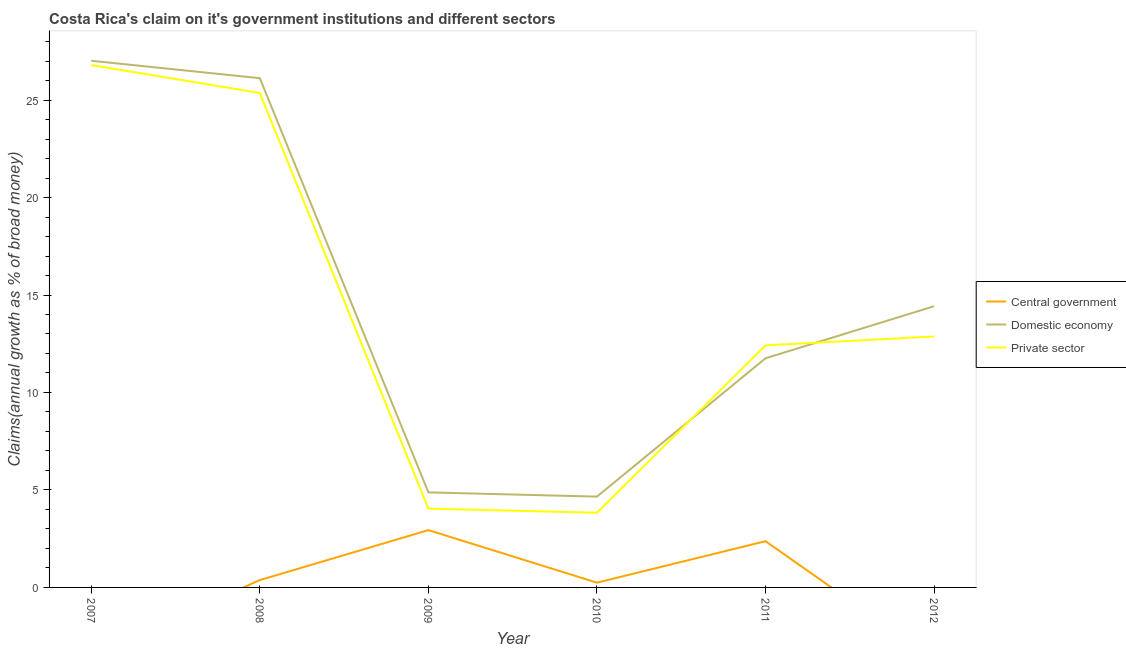Does the line corresponding to percentage of claim on the private sector intersect with the line corresponding to percentage of claim on the domestic economy?
Make the answer very short. Yes. What is the percentage of claim on the domestic economy in 2011?
Your response must be concise. 11.75. Across all years, what is the maximum percentage of claim on the domestic economy?
Provide a succinct answer. 27.02. In which year was the percentage of claim on the private sector maximum?
Ensure brevity in your answer.  2007. What is the total percentage of claim on the central government in the graph?
Keep it short and to the point. 5.93. What is the difference between the percentage of claim on the private sector in 2007 and that in 2010?
Your response must be concise. 22.96. What is the difference between the percentage of claim on the domestic economy in 2012 and the percentage of claim on the private sector in 2009?
Offer a terse response. 10.38. What is the average percentage of claim on the domestic economy per year?
Give a very brief answer. 14.81. In the year 2008, what is the difference between the percentage of claim on the domestic economy and percentage of claim on the central government?
Your response must be concise. 25.75. In how many years, is the percentage of claim on the central government greater than 16 %?
Offer a very short reply. 0. What is the ratio of the percentage of claim on the private sector in 2007 to that in 2009?
Your response must be concise. 6.63. Is the percentage of claim on the private sector in 2009 less than that in 2011?
Your response must be concise. Yes. Is the difference between the percentage of claim on the central government in 2008 and 2010 greater than the difference between the percentage of claim on the private sector in 2008 and 2010?
Your answer should be compact. No. What is the difference between the highest and the second highest percentage of claim on the domestic economy?
Give a very brief answer. 0.89. What is the difference between the highest and the lowest percentage of claim on the domestic economy?
Give a very brief answer. 22.36. Is it the case that in every year, the sum of the percentage of claim on the central government and percentage of claim on the domestic economy is greater than the percentage of claim on the private sector?
Offer a very short reply. Yes. Does the percentage of claim on the central government monotonically increase over the years?
Provide a succinct answer. No. Is the percentage of claim on the domestic economy strictly greater than the percentage of claim on the central government over the years?
Offer a terse response. Yes. Is the percentage of claim on the domestic economy strictly less than the percentage of claim on the private sector over the years?
Your answer should be very brief. No. How many lines are there?
Offer a terse response. 3. How many years are there in the graph?
Offer a terse response. 6. What is the difference between two consecutive major ticks on the Y-axis?
Provide a succinct answer. 5. Are the values on the major ticks of Y-axis written in scientific E-notation?
Keep it short and to the point. No. Does the graph contain any zero values?
Offer a very short reply. Yes. Does the graph contain grids?
Keep it short and to the point. No. How many legend labels are there?
Keep it short and to the point. 3. How are the legend labels stacked?
Your answer should be compact. Vertical. What is the title of the graph?
Your answer should be compact. Costa Rica's claim on it's government institutions and different sectors. Does "Solid fuel" appear as one of the legend labels in the graph?
Provide a succinct answer. No. What is the label or title of the X-axis?
Provide a short and direct response. Year. What is the label or title of the Y-axis?
Ensure brevity in your answer.  Claims(annual growth as % of broad money). What is the Claims(annual growth as % of broad money) of Central government in 2007?
Ensure brevity in your answer.  0. What is the Claims(annual growth as % of broad money) in Domestic economy in 2007?
Give a very brief answer. 27.02. What is the Claims(annual growth as % of broad money) in Private sector in 2007?
Your answer should be very brief. 26.8. What is the Claims(annual growth as % of broad money) of Central government in 2008?
Your response must be concise. 0.38. What is the Claims(annual growth as % of broad money) in Domestic economy in 2008?
Offer a terse response. 26.12. What is the Claims(annual growth as % of broad money) in Private sector in 2008?
Offer a terse response. 25.36. What is the Claims(annual growth as % of broad money) of Central government in 2009?
Provide a succinct answer. 2.94. What is the Claims(annual growth as % of broad money) of Domestic economy in 2009?
Offer a terse response. 4.88. What is the Claims(annual growth as % of broad money) in Private sector in 2009?
Your answer should be very brief. 4.04. What is the Claims(annual growth as % of broad money) in Central government in 2010?
Offer a very short reply. 0.24. What is the Claims(annual growth as % of broad money) in Domestic economy in 2010?
Provide a short and direct response. 4.66. What is the Claims(annual growth as % of broad money) of Private sector in 2010?
Offer a terse response. 3.83. What is the Claims(annual growth as % of broad money) in Central government in 2011?
Your answer should be very brief. 2.37. What is the Claims(annual growth as % of broad money) in Domestic economy in 2011?
Give a very brief answer. 11.75. What is the Claims(annual growth as % of broad money) of Private sector in 2011?
Provide a succinct answer. 12.42. What is the Claims(annual growth as % of broad money) of Domestic economy in 2012?
Your answer should be very brief. 14.42. What is the Claims(annual growth as % of broad money) in Private sector in 2012?
Your response must be concise. 12.87. Across all years, what is the maximum Claims(annual growth as % of broad money) in Central government?
Your answer should be very brief. 2.94. Across all years, what is the maximum Claims(annual growth as % of broad money) of Domestic economy?
Give a very brief answer. 27.02. Across all years, what is the maximum Claims(annual growth as % of broad money) in Private sector?
Keep it short and to the point. 26.8. Across all years, what is the minimum Claims(annual growth as % of broad money) in Central government?
Keep it short and to the point. 0. Across all years, what is the minimum Claims(annual growth as % of broad money) in Domestic economy?
Offer a very short reply. 4.66. Across all years, what is the minimum Claims(annual growth as % of broad money) in Private sector?
Provide a succinct answer. 3.83. What is the total Claims(annual growth as % of broad money) in Central government in the graph?
Ensure brevity in your answer.  5.93. What is the total Claims(annual growth as % of broad money) of Domestic economy in the graph?
Offer a very short reply. 88.85. What is the total Claims(annual growth as % of broad money) of Private sector in the graph?
Your response must be concise. 85.32. What is the difference between the Claims(annual growth as % of broad money) of Domestic economy in 2007 and that in 2008?
Provide a short and direct response. 0.89. What is the difference between the Claims(annual growth as % of broad money) of Private sector in 2007 and that in 2008?
Your answer should be compact. 1.43. What is the difference between the Claims(annual growth as % of broad money) of Domestic economy in 2007 and that in 2009?
Provide a succinct answer. 22.14. What is the difference between the Claims(annual growth as % of broad money) of Private sector in 2007 and that in 2009?
Provide a short and direct response. 22.75. What is the difference between the Claims(annual growth as % of broad money) of Domestic economy in 2007 and that in 2010?
Make the answer very short. 22.36. What is the difference between the Claims(annual growth as % of broad money) in Private sector in 2007 and that in 2010?
Provide a succinct answer. 22.96. What is the difference between the Claims(annual growth as % of broad money) in Domestic economy in 2007 and that in 2011?
Offer a terse response. 15.26. What is the difference between the Claims(annual growth as % of broad money) of Private sector in 2007 and that in 2011?
Your answer should be compact. 14.38. What is the difference between the Claims(annual growth as % of broad money) in Domestic economy in 2007 and that in 2012?
Provide a short and direct response. 12.59. What is the difference between the Claims(annual growth as % of broad money) of Private sector in 2007 and that in 2012?
Ensure brevity in your answer.  13.92. What is the difference between the Claims(annual growth as % of broad money) of Central government in 2008 and that in 2009?
Provide a short and direct response. -2.56. What is the difference between the Claims(annual growth as % of broad money) of Domestic economy in 2008 and that in 2009?
Give a very brief answer. 21.25. What is the difference between the Claims(annual growth as % of broad money) of Private sector in 2008 and that in 2009?
Your response must be concise. 21.32. What is the difference between the Claims(annual growth as % of broad money) of Central government in 2008 and that in 2010?
Provide a short and direct response. 0.13. What is the difference between the Claims(annual growth as % of broad money) in Domestic economy in 2008 and that in 2010?
Provide a short and direct response. 21.46. What is the difference between the Claims(annual growth as % of broad money) in Private sector in 2008 and that in 2010?
Give a very brief answer. 21.53. What is the difference between the Claims(annual growth as % of broad money) of Central government in 2008 and that in 2011?
Ensure brevity in your answer.  -2. What is the difference between the Claims(annual growth as % of broad money) of Domestic economy in 2008 and that in 2011?
Ensure brevity in your answer.  14.37. What is the difference between the Claims(annual growth as % of broad money) of Private sector in 2008 and that in 2011?
Offer a very short reply. 12.94. What is the difference between the Claims(annual growth as % of broad money) of Domestic economy in 2008 and that in 2012?
Give a very brief answer. 11.7. What is the difference between the Claims(annual growth as % of broad money) in Private sector in 2008 and that in 2012?
Offer a terse response. 12.49. What is the difference between the Claims(annual growth as % of broad money) of Central government in 2009 and that in 2010?
Offer a very short reply. 2.7. What is the difference between the Claims(annual growth as % of broad money) in Domestic economy in 2009 and that in 2010?
Make the answer very short. 0.22. What is the difference between the Claims(annual growth as % of broad money) in Private sector in 2009 and that in 2010?
Give a very brief answer. 0.21. What is the difference between the Claims(annual growth as % of broad money) of Central government in 2009 and that in 2011?
Keep it short and to the point. 0.57. What is the difference between the Claims(annual growth as % of broad money) of Domestic economy in 2009 and that in 2011?
Your answer should be compact. -6.88. What is the difference between the Claims(annual growth as % of broad money) in Private sector in 2009 and that in 2011?
Ensure brevity in your answer.  -8.38. What is the difference between the Claims(annual growth as % of broad money) of Domestic economy in 2009 and that in 2012?
Your answer should be very brief. -9.55. What is the difference between the Claims(annual growth as % of broad money) in Private sector in 2009 and that in 2012?
Provide a short and direct response. -8.83. What is the difference between the Claims(annual growth as % of broad money) in Central government in 2010 and that in 2011?
Your answer should be compact. -2.13. What is the difference between the Claims(annual growth as % of broad money) in Domestic economy in 2010 and that in 2011?
Your response must be concise. -7.1. What is the difference between the Claims(annual growth as % of broad money) of Private sector in 2010 and that in 2011?
Give a very brief answer. -8.58. What is the difference between the Claims(annual growth as % of broad money) in Domestic economy in 2010 and that in 2012?
Give a very brief answer. -9.77. What is the difference between the Claims(annual growth as % of broad money) in Private sector in 2010 and that in 2012?
Make the answer very short. -9.04. What is the difference between the Claims(annual growth as % of broad money) in Domestic economy in 2011 and that in 2012?
Your answer should be compact. -2.67. What is the difference between the Claims(annual growth as % of broad money) in Private sector in 2011 and that in 2012?
Provide a short and direct response. -0.46. What is the difference between the Claims(annual growth as % of broad money) in Domestic economy in 2007 and the Claims(annual growth as % of broad money) in Private sector in 2008?
Your answer should be compact. 1.65. What is the difference between the Claims(annual growth as % of broad money) of Domestic economy in 2007 and the Claims(annual growth as % of broad money) of Private sector in 2009?
Provide a succinct answer. 22.97. What is the difference between the Claims(annual growth as % of broad money) in Domestic economy in 2007 and the Claims(annual growth as % of broad money) in Private sector in 2010?
Keep it short and to the point. 23.18. What is the difference between the Claims(annual growth as % of broad money) of Domestic economy in 2007 and the Claims(annual growth as % of broad money) of Private sector in 2011?
Offer a very short reply. 14.6. What is the difference between the Claims(annual growth as % of broad money) in Domestic economy in 2007 and the Claims(annual growth as % of broad money) in Private sector in 2012?
Offer a very short reply. 14.14. What is the difference between the Claims(annual growth as % of broad money) in Central government in 2008 and the Claims(annual growth as % of broad money) in Domestic economy in 2009?
Ensure brevity in your answer.  -4.5. What is the difference between the Claims(annual growth as % of broad money) in Central government in 2008 and the Claims(annual growth as % of broad money) in Private sector in 2009?
Your answer should be very brief. -3.67. What is the difference between the Claims(annual growth as % of broad money) of Domestic economy in 2008 and the Claims(annual growth as % of broad money) of Private sector in 2009?
Offer a very short reply. 22.08. What is the difference between the Claims(annual growth as % of broad money) of Central government in 2008 and the Claims(annual growth as % of broad money) of Domestic economy in 2010?
Offer a very short reply. -4.28. What is the difference between the Claims(annual growth as % of broad money) of Central government in 2008 and the Claims(annual growth as % of broad money) of Private sector in 2010?
Your answer should be very brief. -3.46. What is the difference between the Claims(annual growth as % of broad money) of Domestic economy in 2008 and the Claims(annual growth as % of broad money) of Private sector in 2010?
Give a very brief answer. 22.29. What is the difference between the Claims(annual growth as % of broad money) of Central government in 2008 and the Claims(annual growth as % of broad money) of Domestic economy in 2011?
Provide a short and direct response. -11.38. What is the difference between the Claims(annual growth as % of broad money) of Central government in 2008 and the Claims(annual growth as % of broad money) of Private sector in 2011?
Offer a terse response. -12.04. What is the difference between the Claims(annual growth as % of broad money) of Domestic economy in 2008 and the Claims(annual growth as % of broad money) of Private sector in 2011?
Your answer should be compact. 13.7. What is the difference between the Claims(annual growth as % of broad money) in Central government in 2008 and the Claims(annual growth as % of broad money) in Domestic economy in 2012?
Ensure brevity in your answer.  -14.05. What is the difference between the Claims(annual growth as % of broad money) in Central government in 2008 and the Claims(annual growth as % of broad money) in Private sector in 2012?
Offer a terse response. -12.5. What is the difference between the Claims(annual growth as % of broad money) in Domestic economy in 2008 and the Claims(annual growth as % of broad money) in Private sector in 2012?
Provide a short and direct response. 13.25. What is the difference between the Claims(annual growth as % of broad money) of Central government in 2009 and the Claims(annual growth as % of broad money) of Domestic economy in 2010?
Ensure brevity in your answer.  -1.72. What is the difference between the Claims(annual growth as % of broad money) in Central government in 2009 and the Claims(annual growth as % of broad money) in Private sector in 2010?
Keep it short and to the point. -0.89. What is the difference between the Claims(annual growth as % of broad money) in Domestic economy in 2009 and the Claims(annual growth as % of broad money) in Private sector in 2010?
Provide a short and direct response. 1.04. What is the difference between the Claims(annual growth as % of broad money) in Central government in 2009 and the Claims(annual growth as % of broad money) in Domestic economy in 2011?
Give a very brief answer. -8.81. What is the difference between the Claims(annual growth as % of broad money) of Central government in 2009 and the Claims(annual growth as % of broad money) of Private sector in 2011?
Make the answer very short. -9.48. What is the difference between the Claims(annual growth as % of broad money) of Domestic economy in 2009 and the Claims(annual growth as % of broad money) of Private sector in 2011?
Your answer should be very brief. -7.54. What is the difference between the Claims(annual growth as % of broad money) of Central government in 2009 and the Claims(annual growth as % of broad money) of Domestic economy in 2012?
Your answer should be very brief. -11.48. What is the difference between the Claims(annual growth as % of broad money) of Central government in 2009 and the Claims(annual growth as % of broad money) of Private sector in 2012?
Provide a short and direct response. -9.93. What is the difference between the Claims(annual growth as % of broad money) in Domestic economy in 2009 and the Claims(annual growth as % of broad money) in Private sector in 2012?
Keep it short and to the point. -8. What is the difference between the Claims(annual growth as % of broad money) in Central government in 2010 and the Claims(annual growth as % of broad money) in Domestic economy in 2011?
Give a very brief answer. -11.51. What is the difference between the Claims(annual growth as % of broad money) in Central government in 2010 and the Claims(annual growth as % of broad money) in Private sector in 2011?
Provide a succinct answer. -12.17. What is the difference between the Claims(annual growth as % of broad money) in Domestic economy in 2010 and the Claims(annual growth as % of broad money) in Private sector in 2011?
Your answer should be compact. -7.76. What is the difference between the Claims(annual growth as % of broad money) of Central government in 2010 and the Claims(annual growth as % of broad money) of Domestic economy in 2012?
Make the answer very short. -14.18. What is the difference between the Claims(annual growth as % of broad money) in Central government in 2010 and the Claims(annual growth as % of broad money) in Private sector in 2012?
Your answer should be very brief. -12.63. What is the difference between the Claims(annual growth as % of broad money) of Domestic economy in 2010 and the Claims(annual growth as % of broad money) of Private sector in 2012?
Make the answer very short. -8.21. What is the difference between the Claims(annual growth as % of broad money) of Central government in 2011 and the Claims(annual growth as % of broad money) of Domestic economy in 2012?
Provide a succinct answer. -12.05. What is the difference between the Claims(annual growth as % of broad money) of Central government in 2011 and the Claims(annual growth as % of broad money) of Private sector in 2012?
Give a very brief answer. -10.5. What is the difference between the Claims(annual growth as % of broad money) of Domestic economy in 2011 and the Claims(annual growth as % of broad money) of Private sector in 2012?
Offer a very short reply. -1.12. What is the average Claims(annual growth as % of broad money) of Central government per year?
Offer a very short reply. 0.99. What is the average Claims(annual growth as % of broad money) of Domestic economy per year?
Offer a very short reply. 14.81. What is the average Claims(annual growth as % of broad money) in Private sector per year?
Make the answer very short. 14.22. In the year 2007, what is the difference between the Claims(annual growth as % of broad money) in Domestic economy and Claims(annual growth as % of broad money) in Private sector?
Offer a terse response. 0.22. In the year 2008, what is the difference between the Claims(annual growth as % of broad money) of Central government and Claims(annual growth as % of broad money) of Domestic economy?
Your response must be concise. -25.75. In the year 2008, what is the difference between the Claims(annual growth as % of broad money) in Central government and Claims(annual growth as % of broad money) in Private sector?
Provide a succinct answer. -24.99. In the year 2008, what is the difference between the Claims(annual growth as % of broad money) of Domestic economy and Claims(annual growth as % of broad money) of Private sector?
Provide a succinct answer. 0.76. In the year 2009, what is the difference between the Claims(annual growth as % of broad money) in Central government and Claims(annual growth as % of broad money) in Domestic economy?
Your answer should be very brief. -1.94. In the year 2009, what is the difference between the Claims(annual growth as % of broad money) in Central government and Claims(annual growth as % of broad money) in Private sector?
Give a very brief answer. -1.1. In the year 2009, what is the difference between the Claims(annual growth as % of broad money) of Domestic economy and Claims(annual growth as % of broad money) of Private sector?
Offer a terse response. 0.83. In the year 2010, what is the difference between the Claims(annual growth as % of broad money) in Central government and Claims(annual growth as % of broad money) in Domestic economy?
Offer a terse response. -4.41. In the year 2010, what is the difference between the Claims(annual growth as % of broad money) in Central government and Claims(annual growth as % of broad money) in Private sector?
Your answer should be compact. -3.59. In the year 2010, what is the difference between the Claims(annual growth as % of broad money) of Domestic economy and Claims(annual growth as % of broad money) of Private sector?
Provide a short and direct response. 0.83. In the year 2011, what is the difference between the Claims(annual growth as % of broad money) in Central government and Claims(annual growth as % of broad money) in Domestic economy?
Give a very brief answer. -9.38. In the year 2011, what is the difference between the Claims(annual growth as % of broad money) in Central government and Claims(annual growth as % of broad money) in Private sector?
Ensure brevity in your answer.  -10.05. In the year 2011, what is the difference between the Claims(annual growth as % of broad money) of Domestic economy and Claims(annual growth as % of broad money) of Private sector?
Make the answer very short. -0.66. In the year 2012, what is the difference between the Claims(annual growth as % of broad money) in Domestic economy and Claims(annual growth as % of broad money) in Private sector?
Provide a succinct answer. 1.55. What is the ratio of the Claims(annual growth as % of broad money) of Domestic economy in 2007 to that in 2008?
Make the answer very short. 1.03. What is the ratio of the Claims(annual growth as % of broad money) in Private sector in 2007 to that in 2008?
Offer a very short reply. 1.06. What is the ratio of the Claims(annual growth as % of broad money) of Domestic economy in 2007 to that in 2009?
Keep it short and to the point. 5.54. What is the ratio of the Claims(annual growth as % of broad money) in Private sector in 2007 to that in 2009?
Offer a very short reply. 6.63. What is the ratio of the Claims(annual growth as % of broad money) in Domestic economy in 2007 to that in 2010?
Give a very brief answer. 5.8. What is the ratio of the Claims(annual growth as % of broad money) of Private sector in 2007 to that in 2010?
Offer a very short reply. 6.99. What is the ratio of the Claims(annual growth as % of broad money) of Domestic economy in 2007 to that in 2011?
Your answer should be very brief. 2.3. What is the ratio of the Claims(annual growth as % of broad money) in Private sector in 2007 to that in 2011?
Ensure brevity in your answer.  2.16. What is the ratio of the Claims(annual growth as % of broad money) in Domestic economy in 2007 to that in 2012?
Offer a very short reply. 1.87. What is the ratio of the Claims(annual growth as % of broad money) in Private sector in 2007 to that in 2012?
Keep it short and to the point. 2.08. What is the ratio of the Claims(annual growth as % of broad money) of Central government in 2008 to that in 2009?
Give a very brief answer. 0.13. What is the ratio of the Claims(annual growth as % of broad money) of Domestic economy in 2008 to that in 2009?
Provide a short and direct response. 5.36. What is the ratio of the Claims(annual growth as % of broad money) in Private sector in 2008 to that in 2009?
Ensure brevity in your answer.  6.28. What is the ratio of the Claims(annual growth as % of broad money) of Central government in 2008 to that in 2010?
Your answer should be very brief. 1.54. What is the ratio of the Claims(annual growth as % of broad money) of Domestic economy in 2008 to that in 2010?
Provide a short and direct response. 5.61. What is the ratio of the Claims(annual growth as % of broad money) in Private sector in 2008 to that in 2010?
Make the answer very short. 6.62. What is the ratio of the Claims(annual growth as % of broad money) of Central government in 2008 to that in 2011?
Ensure brevity in your answer.  0.16. What is the ratio of the Claims(annual growth as % of broad money) of Domestic economy in 2008 to that in 2011?
Your answer should be very brief. 2.22. What is the ratio of the Claims(annual growth as % of broad money) in Private sector in 2008 to that in 2011?
Offer a very short reply. 2.04. What is the ratio of the Claims(annual growth as % of broad money) of Domestic economy in 2008 to that in 2012?
Make the answer very short. 1.81. What is the ratio of the Claims(annual growth as % of broad money) of Private sector in 2008 to that in 2012?
Provide a succinct answer. 1.97. What is the ratio of the Claims(annual growth as % of broad money) of Central government in 2009 to that in 2010?
Offer a terse response. 12.02. What is the ratio of the Claims(annual growth as % of broad money) in Domestic economy in 2009 to that in 2010?
Provide a short and direct response. 1.05. What is the ratio of the Claims(annual growth as % of broad money) in Private sector in 2009 to that in 2010?
Your response must be concise. 1.05. What is the ratio of the Claims(annual growth as % of broad money) in Central government in 2009 to that in 2011?
Offer a terse response. 1.24. What is the ratio of the Claims(annual growth as % of broad money) of Domestic economy in 2009 to that in 2011?
Offer a terse response. 0.41. What is the ratio of the Claims(annual growth as % of broad money) of Private sector in 2009 to that in 2011?
Offer a terse response. 0.33. What is the ratio of the Claims(annual growth as % of broad money) in Domestic economy in 2009 to that in 2012?
Keep it short and to the point. 0.34. What is the ratio of the Claims(annual growth as % of broad money) in Private sector in 2009 to that in 2012?
Give a very brief answer. 0.31. What is the ratio of the Claims(annual growth as % of broad money) of Central government in 2010 to that in 2011?
Your answer should be very brief. 0.1. What is the ratio of the Claims(annual growth as % of broad money) in Domestic economy in 2010 to that in 2011?
Offer a terse response. 0.4. What is the ratio of the Claims(annual growth as % of broad money) of Private sector in 2010 to that in 2011?
Your answer should be compact. 0.31. What is the ratio of the Claims(annual growth as % of broad money) in Domestic economy in 2010 to that in 2012?
Provide a short and direct response. 0.32. What is the ratio of the Claims(annual growth as % of broad money) of Private sector in 2010 to that in 2012?
Your response must be concise. 0.3. What is the ratio of the Claims(annual growth as % of broad money) of Domestic economy in 2011 to that in 2012?
Offer a very short reply. 0.81. What is the ratio of the Claims(annual growth as % of broad money) in Private sector in 2011 to that in 2012?
Make the answer very short. 0.96. What is the difference between the highest and the second highest Claims(annual growth as % of broad money) in Central government?
Make the answer very short. 0.57. What is the difference between the highest and the second highest Claims(annual growth as % of broad money) of Domestic economy?
Make the answer very short. 0.89. What is the difference between the highest and the second highest Claims(annual growth as % of broad money) of Private sector?
Offer a very short reply. 1.43. What is the difference between the highest and the lowest Claims(annual growth as % of broad money) of Central government?
Offer a very short reply. 2.94. What is the difference between the highest and the lowest Claims(annual growth as % of broad money) of Domestic economy?
Your response must be concise. 22.36. What is the difference between the highest and the lowest Claims(annual growth as % of broad money) of Private sector?
Ensure brevity in your answer.  22.96. 